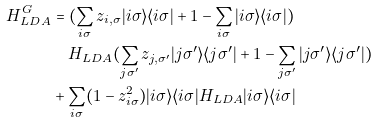Convert formula to latex. <formula><loc_0><loc_0><loc_500><loc_500>H _ { L D A } ^ { G } & = ( \sum _ { i \sigma } z _ { i , \sigma } | i \sigma \rangle \langle i \sigma | + 1 - \sum _ { i \sigma } | i \sigma \rangle \langle i \sigma | ) \\ & \quad H _ { L D A } ( \sum _ { j \sigma ^ { \prime } } z _ { j , \sigma ^ { \prime } } | j \sigma ^ { \prime } \rangle \langle j \sigma ^ { \prime } | + 1 - \sum _ { j \sigma ^ { \prime } } | j \sigma ^ { \prime } \rangle \langle j \sigma ^ { \prime } | ) \\ & + \sum _ { i \sigma } ( 1 - z _ { i \sigma } ^ { 2 } ) | i \sigma \rangle \langle i \sigma | H _ { L D A } | i \sigma \rangle \langle i \sigma |</formula> 